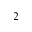<formula> <loc_0><loc_0><loc_500><loc_500>^ { 2 }</formula> 